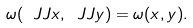Convert formula to latex. <formula><loc_0><loc_0><loc_500><loc_500>\omega ( \ J J x , \ J J y ) = \omega ( x , y ) .</formula> 